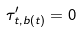<formula> <loc_0><loc_0><loc_500><loc_500>\tau ^ { \prime } _ { t , b ( t ) } = 0 \quad</formula> 